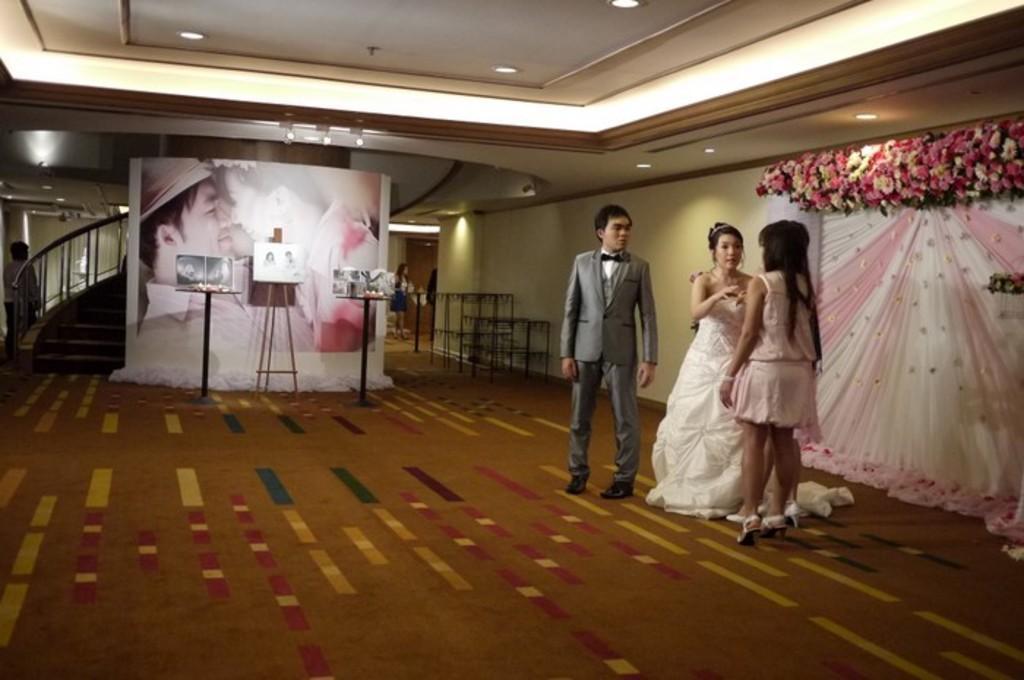In one or two sentences, can you explain what this image depicts? In the picture I can see two women on the right side and looks like they are having a conversation. There is a man beside a woman and he is wearing a suit. I can see the flower decoration on the wall on the right side. In the background, I can see the photo frame. There is a lighting arrangement on the roof. There is a staircase and a man on the left side. I can see two tables and a drawing board stand on the floor. 